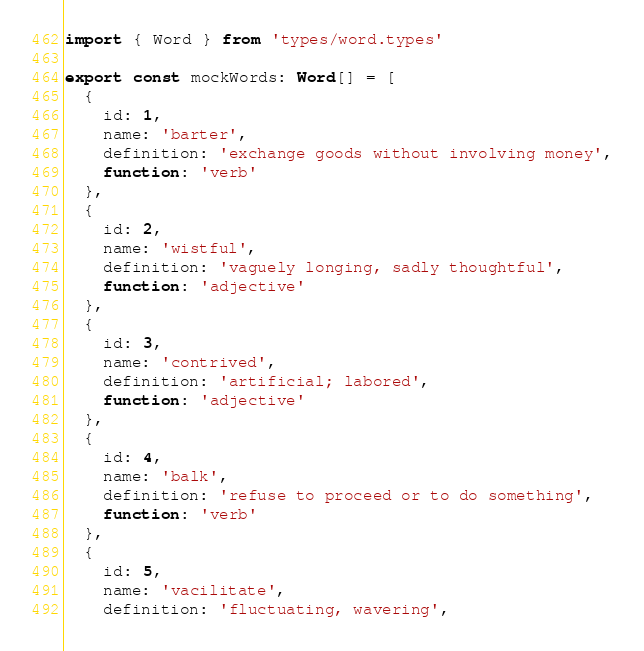<code> <loc_0><loc_0><loc_500><loc_500><_TypeScript_>import { Word } from 'types/word.types'

export const mockWords: Word[] = [
  {
    id: 1,
    name: 'barter',
    definition: 'exchange goods without involving money',
    function: 'verb'
  },
  {
    id: 2,
    name: 'wistful',
    definition: 'vaguely longing, sadly thoughtful',
    function: 'adjective'
  },
  {
    id: 3,
    name: 'contrived',
    definition: 'artificial; labored',
    function: 'adjective'
  },
  {
    id: 4,
    name: 'balk',
    definition: 'refuse to proceed or to do something',
    function: 'verb'
  },
  {
    id: 5,
    name: 'vacilitate',
    definition: 'fluctuating, wavering',</code> 